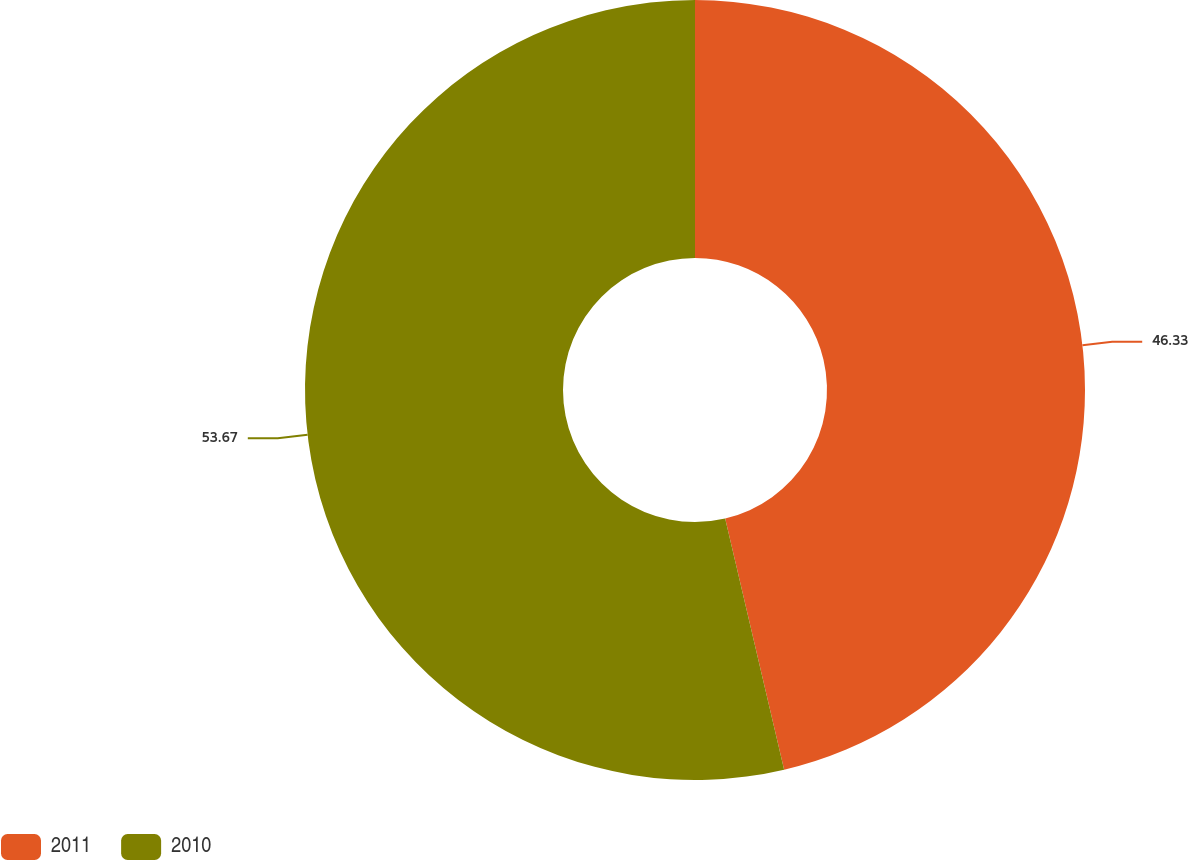Convert chart. <chart><loc_0><loc_0><loc_500><loc_500><pie_chart><fcel>2011<fcel>2010<nl><fcel>46.33%<fcel>53.67%<nl></chart> 